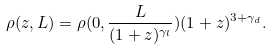Convert formula to latex. <formula><loc_0><loc_0><loc_500><loc_500>\rho ( z , L ) = \rho ( 0 , \frac { L } { ( 1 + z ) ^ { \gamma _ { l } } } ) ( 1 + z ) ^ { 3 + \gamma _ { d } } .</formula> 